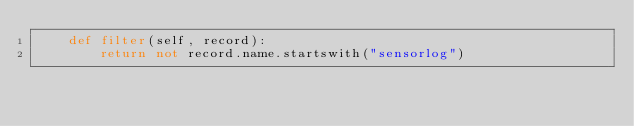Convert code to text. <code><loc_0><loc_0><loc_500><loc_500><_Python_>    def filter(self, record):
        return not record.name.startswith("sensorlog")
</code> 